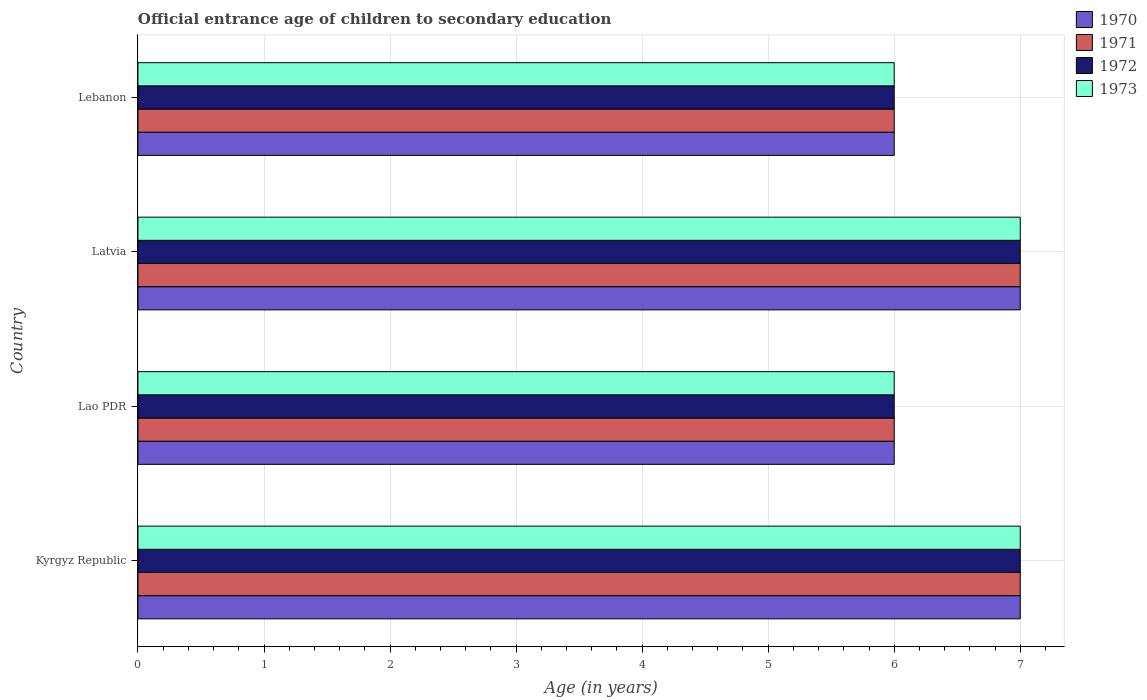Are the number of bars per tick equal to the number of legend labels?
Provide a short and direct response. Yes. Are the number of bars on each tick of the Y-axis equal?
Make the answer very short. Yes. How many bars are there on the 1st tick from the top?
Provide a short and direct response. 4. What is the label of the 1st group of bars from the top?
Offer a very short reply. Lebanon. What is the secondary school starting age of children in 1970 in Latvia?
Give a very brief answer. 7. Across all countries, what is the minimum secondary school starting age of children in 1971?
Your response must be concise. 6. In which country was the secondary school starting age of children in 1970 maximum?
Ensure brevity in your answer.  Kyrgyz Republic. In which country was the secondary school starting age of children in 1973 minimum?
Your answer should be very brief. Lao PDR. In how many countries, is the secondary school starting age of children in 1972 greater than 3.6 years?
Give a very brief answer. 4. What is the difference between the highest and the second highest secondary school starting age of children in 1973?
Your response must be concise. 0. What is the difference between the highest and the lowest secondary school starting age of children in 1972?
Offer a terse response. 1. What does the 1st bar from the top in Latvia represents?
Your answer should be very brief. 1973. What does the 1st bar from the bottom in Lebanon represents?
Provide a succinct answer. 1970. Is it the case that in every country, the sum of the secondary school starting age of children in 1970 and secondary school starting age of children in 1972 is greater than the secondary school starting age of children in 1973?
Offer a very short reply. Yes. How many bars are there?
Make the answer very short. 16. Are all the bars in the graph horizontal?
Make the answer very short. Yes. How many countries are there in the graph?
Offer a very short reply. 4. Are the values on the major ticks of X-axis written in scientific E-notation?
Keep it short and to the point. No. Does the graph contain any zero values?
Keep it short and to the point. No. Does the graph contain grids?
Give a very brief answer. Yes. Where does the legend appear in the graph?
Offer a terse response. Top right. What is the title of the graph?
Your answer should be compact. Official entrance age of children to secondary education. Does "1984" appear as one of the legend labels in the graph?
Provide a succinct answer. No. What is the label or title of the X-axis?
Your response must be concise. Age (in years). What is the label or title of the Y-axis?
Keep it short and to the point. Country. What is the Age (in years) of 1971 in Kyrgyz Republic?
Your answer should be very brief. 7. What is the Age (in years) of 1972 in Kyrgyz Republic?
Keep it short and to the point. 7. What is the Age (in years) in 1970 in Lao PDR?
Provide a short and direct response. 6. What is the Age (in years) of 1971 in Lao PDR?
Your answer should be compact. 6. What is the Age (in years) in 1972 in Lao PDR?
Your answer should be very brief. 6. What is the Age (in years) of 1973 in Lao PDR?
Your response must be concise. 6. What is the Age (in years) of 1970 in Lebanon?
Make the answer very short. 6. What is the Age (in years) in 1971 in Lebanon?
Your answer should be compact. 6. What is the Age (in years) in 1972 in Lebanon?
Ensure brevity in your answer.  6. Across all countries, what is the maximum Age (in years) in 1970?
Provide a succinct answer. 7. Across all countries, what is the maximum Age (in years) in 1972?
Offer a very short reply. 7. Across all countries, what is the maximum Age (in years) of 1973?
Your response must be concise. 7. Across all countries, what is the minimum Age (in years) of 1971?
Ensure brevity in your answer.  6. Across all countries, what is the minimum Age (in years) in 1973?
Offer a terse response. 6. What is the total Age (in years) in 1972 in the graph?
Provide a short and direct response. 26. What is the total Age (in years) of 1973 in the graph?
Offer a very short reply. 26. What is the difference between the Age (in years) of 1971 in Kyrgyz Republic and that in Lao PDR?
Your answer should be very brief. 1. What is the difference between the Age (in years) of 1972 in Kyrgyz Republic and that in Lao PDR?
Make the answer very short. 1. What is the difference between the Age (in years) of 1973 in Kyrgyz Republic and that in Lao PDR?
Your answer should be very brief. 1. What is the difference between the Age (in years) of 1970 in Kyrgyz Republic and that in Latvia?
Provide a succinct answer. 0. What is the difference between the Age (in years) in 1971 in Kyrgyz Republic and that in Latvia?
Offer a very short reply. 0. What is the difference between the Age (in years) of 1970 in Kyrgyz Republic and that in Lebanon?
Make the answer very short. 1. What is the difference between the Age (in years) of 1972 in Kyrgyz Republic and that in Lebanon?
Offer a very short reply. 1. What is the difference between the Age (in years) of 1973 in Kyrgyz Republic and that in Lebanon?
Provide a short and direct response. 1. What is the difference between the Age (in years) of 1972 in Lao PDR and that in Latvia?
Ensure brevity in your answer.  -1. What is the difference between the Age (in years) in 1972 in Lao PDR and that in Lebanon?
Your response must be concise. 0. What is the difference between the Age (in years) of 1970 in Latvia and that in Lebanon?
Offer a terse response. 1. What is the difference between the Age (in years) of 1972 in Latvia and that in Lebanon?
Your answer should be very brief. 1. What is the difference between the Age (in years) of 1973 in Latvia and that in Lebanon?
Offer a terse response. 1. What is the difference between the Age (in years) of 1971 in Kyrgyz Republic and the Age (in years) of 1973 in Lao PDR?
Keep it short and to the point. 1. What is the difference between the Age (in years) of 1970 in Kyrgyz Republic and the Age (in years) of 1971 in Latvia?
Ensure brevity in your answer.  0. What is the difference between the Age (in years) of 1970 in Kyrgyz Republic and the Age (in years) of 1972 in Latvia?
Provide a succinct answer. 0. What is the difference between the Age (in years) in 1970 in Kyrgyz Republic and the Age (in years) in 1973 in Latvia?
Offer a very short reply. 0. What is the difference between the Age (in years) in 1970 in Kyrgyz Republic and the Age (in years) in 1973 in Lebanon?
Your answer should be very brief. 1. What is the difference between the Age (in years) in 1971 in Kyrgyz Republic and the Age (in years) in 1973 in Lebanon?
Offer a terse response. 1. What is the difference between the Age (in years) in 1972 in Kyrgyz Republic and the Age (in years) in 1973 in Lebanon?
Keep it short and to the point. 1. What is the difference between the Age (in years) of 1970 in Lao PDR and the Age (in years) of 1973 in Latvia?
Your answer should be compact. -1. What is the difference between the Age (in years) of 1971 in Lao PDR and the Age (in years) of 1972 in Latvia?
Your answer should be compact. -1. What is the difference between the Age (in years) of 1971 in Lao PDR and the Age (in years) of 1973 in Latvia?
Keep it short and to the point. -1. What is the difference between the Age (in years) of 1970 in Latvia and the Age (in years) of 1972 in Lebanon?
Ensure brevity in your answer.  1. What is the difference between the Age (in years) of 1970 in Latvia and the Age (in years) of 1973 in Lebanon?
Your answer should be compact. 1. What is the difference between the Age (in years) of 1971 in Latvia and the Age (in years) of 1972 in Lebanon?
Your answer should be compact. 1. What is the difference between the Age (in years) of 1972 in Latvia and the Age (in years) of 1973 in Lebanon?
Provide a short and direct response. 1. What is the average Age (in years) of 1970 per country?
Your answer should be compact. 6.5. What is the average Age (in years) in 1971 per country?
Give a very brief answer. 6.5. What is the average Age (in years) in 1973 per country?
Provide a succinct answer. 6.5. What is the difference between the Age (in years) in 1970 and Age (in years) in 1971 in Kyrgyz Republic?
Your answer should be very brief. 0. What is the difference between the Age (in years) of 1971 and Age (in years) of 1972 in Kyrgyz Republic?
Offer a terse response. 0. What is the difference between the Age (in years) in 1970 and Age (in years) in 1971 in Lao PDR?
Offer a very short reply. 0. What is the difference between the Age (in years) of 1970 and Age (in years) of 1972 in Lao PDR?
Your answer should be very brief. 0. What is the difference between the Age (in years) in 1971 and Age (in years) in 1973 in Lao PDR?
Ensure brevity in your answer.  0. What is the difference between the Age (in years) in 1970 and Age (in years) in 1972 in Latvia?
Your response must be concise. 0. What is the difference between the Age (in years) of 1972 and Age (in years) of 1973 in Latvia?
Your response must be concise. 0. What is the difference between the Age (in years) of 1970 and Age (in years) of 1971 in Lebanon?
Give a very brief answer. 0. What is the difference between the Age (in years) of 1970 and Age (in years) of 1973 in Lebanon?
Keep it short and to the point. 0. What is the difference between the Age (in years) of 1971 and Age (in years) of 1973 in Lebanon?
Your response must be concise. 0. What is the ratio of the Age (in years) of 1972 in Kyrgyz Republic to that in Lao PDR?
Your answer should be compact. 1.17. What is the ratio of the Age (in years) in 1973 in Kyrgyz Republic to that in Lao PDR?
Provide a short and direct response. 1.17. What is the ratio of the Age (in years) of 1970 in Kyrgyz Republic to that in Latvia?
Ensure brevity in your answer.  1. What is the ratio of the Age (in years) of 1972 in Kyrgyz Republic to that in Latvia?
Your answer should be compact. 1. What is the ratio of the Age (in years) of 1973 in Kyrgyz Republic to that in Latvia?
Your answer should be compact. 1. What is the ratio of the Age (in years) in 1970 in Kyrgyz Republic to that in Lebanon?
Offer a terse response. 1.17. What is the ratio of the Age (in years) in 1972 in Kyrgyz Republic to that in Lebanon?
Your response must be concise. 1.17. What is the ratio of the Age (in years) of 1973 in Kyrgyz Republic to that in Lebanon?
Give a very brief answer. 1.17. What is the ratio of the Age (in years) of 1971 in Lao PDR to that in Latvia?
Keep it short and to the point. 0.86. What is the ratio of the Age (in years) of 1971 in Lao PDR to that in Lebanon?
Make the answer very short. 1. What is the ratio of the Age (in years) of 1973 in Lao PDR to that in Lebanon?
Ensure brevity in your answer.  1. What is the ratio of the Age (in years) in 1971 in Latvia to that in Lebanon?
Offer a terse response. 1.17. What is the difference between the highest and the second highest Age (in years) of 1970?
Your answer should be compact. 0. What is the difference between the highest and the second highest Age (in years) in 1971?
Your response must be concise. 0. What is the difference between the highest and the second highest Age (in years) in 1972?
Give a very brief answer. 0. What is the difference between the highest and the second highest Age (in years) of 1973?
Ensure brevity in your answer.  0. What is the difference between the highest and the lowest Age (in years) of 1970?
Your answer should be very brief. 1. What is the difference between the highest and the lowest Age (in years) of 1973?
Make the answer very short. 1. 